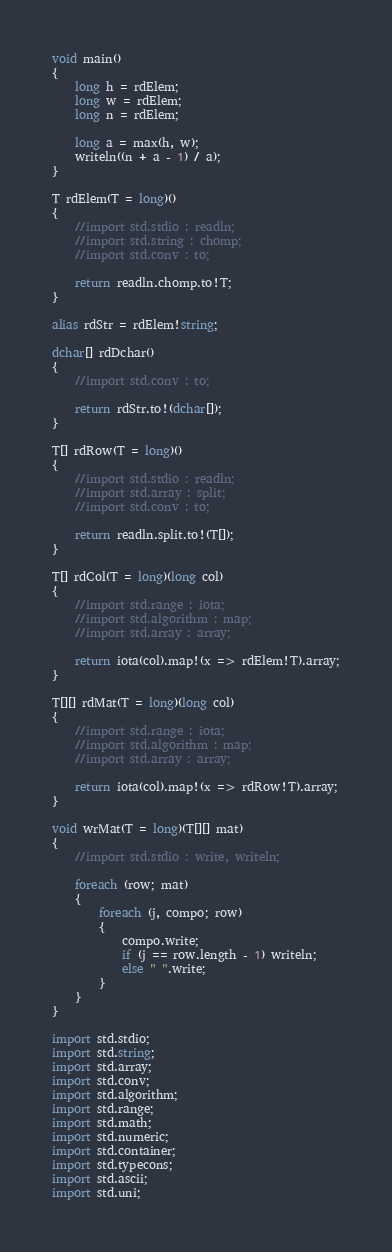<code> <loc_0><loc_0><loc_500><loc_500><_D_>void main()
{
    long h = rdElem;
    long w = rdElem;
    long n = rdElem;

    long a = max(h, w);
    writeln((n + a - 1) / a);
}

T rdElem(T = long)()
{
    //import std.stdio : readln;
    //import std.string : chomp;
    //import std.conv : to;

    return readln.chomp.to!T;
}

alias rdStr = rdElem!string;

dchar[] rdDchar()
{
    //import std.conv : to;

    return rdStr.to!(dchar[]);
}

T[] rdRow(T = long)()
{
    //import std.stdio : readln;
    //import std.array : split;
    //import std.conv : to;

    return readln.split.to!(T[]);
}

T[] rdCol(T = long)(long col)
{
    //import std.range : iota;
    //import std.algorithm : map;
    //import std.array : array;

    return iota(col).map!(x => rdElem!T).array;
}

T[][] rdMat(T = long)(long col)
{
    //import std.range : iota;
    //import std.algorithm : map;
    //import std.array : array;

    return iota(col).map!(x => rdRow!T).array;
}

void wrMat(T = long)(T[][] mat)
{
    //import std.stdio : write, writeln;

    foreach (row; mat)
    {
        foreach (j, compo; row)
        {
            compo.write;
            if (j == row.length - 1) writeln;
            else " ".write;
        }
    }
}

import std.stdio;
import std.string;
import std.array;
import std.conv;
import std.algorithm;
import std.range;
import std.math;
import std.numeric;
import std.container;
import std.typecons;
import std.ascii;
import std.uni;</code> 